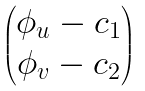<formula> <loc_0><loc_0><loc_500><loc_500>\begin{pmatrix} \phi _ { u } - c _ { 1 } \\ \phi _ { v } - c _ { 2 } \\ \end{pmatrix}</formula> 